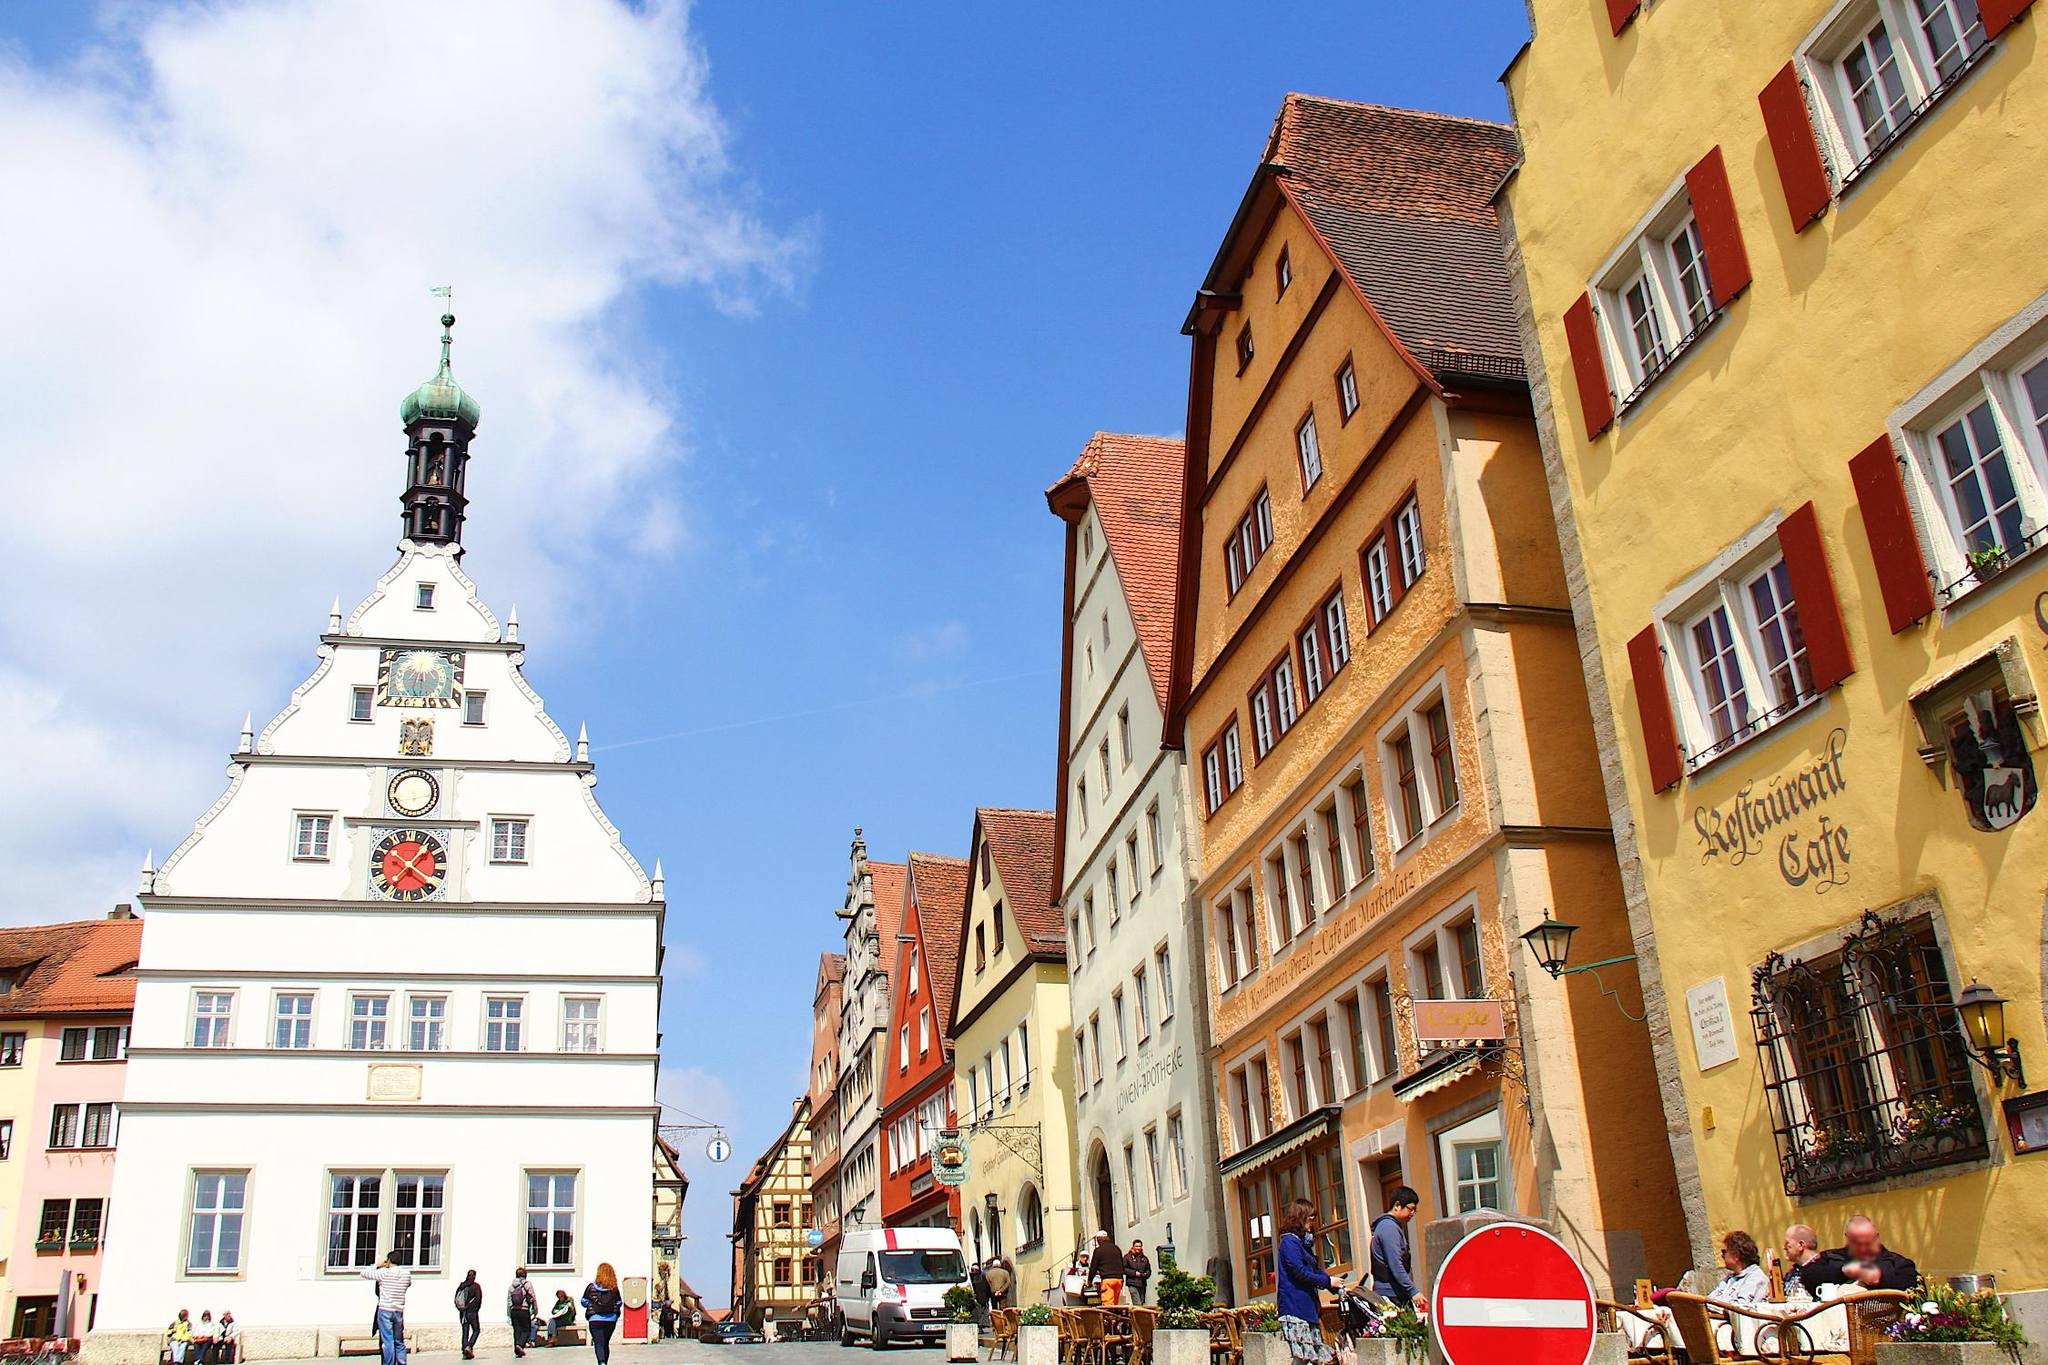What is the historical significance of Rothenburg ob der Tauber? Rothenburg ob der Tauber is well-known for its well-preserved medieval old town, a part of the Romantic Road through southern Germany. The town is encircled by its original fortified walls and has several gates and towers that date back to the Middle Ages. It has been a popular destination for centuries, offering visitors a glimpse into Germany's past and showcasing traditional architecture, cultural heritage, and historic festivals. 